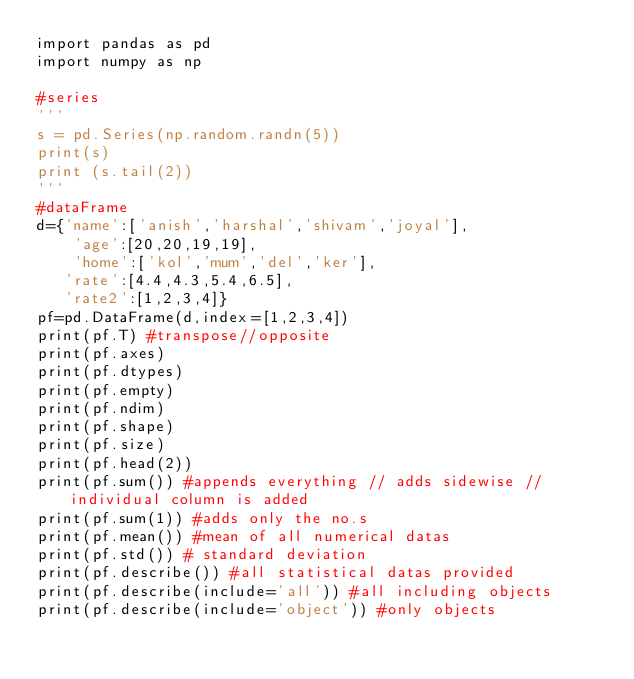Convert code to text. <code><loc_0><loc_0><loc_500><loc_500><_Python_>import pandas as pd
import numpy as np

#series
'''
s = pd.Series(np.random.randn(5))
print(s)
print (s.tail(2))
'''
#dataFrame
d={'name':['anish','harshal','shivam','joyal'],
    'age':[20,20,19,19],
    'home':['kol','mum','del','ker'],
   'rate':[4.4,4.3,5.4,6.5],
   'rate2':[1,2,3,4]}
pf=pd.DataFrame(d,index=[1,2,3,4])
print(pf.T) #transpose//opposite
print(pf.axes)
print(pf.dtypes)
print(pf.empty)
print(pf.ndim)
print(pf.shape)
print(pf.size)
print(pf.head(2))
print(pf.sum()) #appends everything // adds sidewise // individual column is added
print(pf.sum(1)) #adds only the no.s
print(pf.mean()) #mean of all numerical datas
print(pf.std()) # standard deviation
print(pf.describe()) #all statistical datas provided
print(pf.describe(include='all')) #all including objects
print(pf.describe(include='object')) #only objects
</code> 